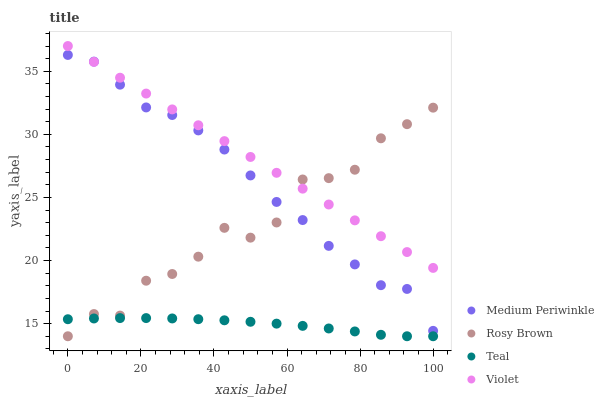Does Teal have the minimum area under the curve?
Answer yes or no. Yes. Does Violet have the maximum area under the curve?
Answer yes or no. Yes. Does Medium Periwinkle have the minimum area under the curve?
Answer yes or no. No. Does Medium Periwinkle have the maximum area under the curve?
Answer yes or no. No. Is Violet the smoothest?
Answer yes or no. Yes. Is Rosy Brown the roughest?
Answer yes or no. Yes. Is Medium Periwinkle the smoothest?
Answer yes or no. No. Is Medium Periwinkle the roughest?
Answer yes or no. No. Does Rosy Brown have the lowest value?
Answer yes or no. Yes. Does Medium Periwinkle have the lowest value?
Answer yes or no. No. Does Violet have the highest value?
Answer yes or no. Yes. Does Medium Periwinkle have the highest value?
Answer yes or no. No. Is Teal less than Medium Periwinkle?
Answer yes or no. Yes. Is Medium Periwinkle greater than Teal?
Answer yes or no. Yes. Does Teal intersect Rosy Brown?
Answer yes or no. Yes. Is Teal less than Rosy Brown?
Answer yes or no. No. Is Teal greater than Rosy Brown?
Answer yes or no. No. Does Teal intersect Medium Periwinkle?
Answer yes or no. No. 